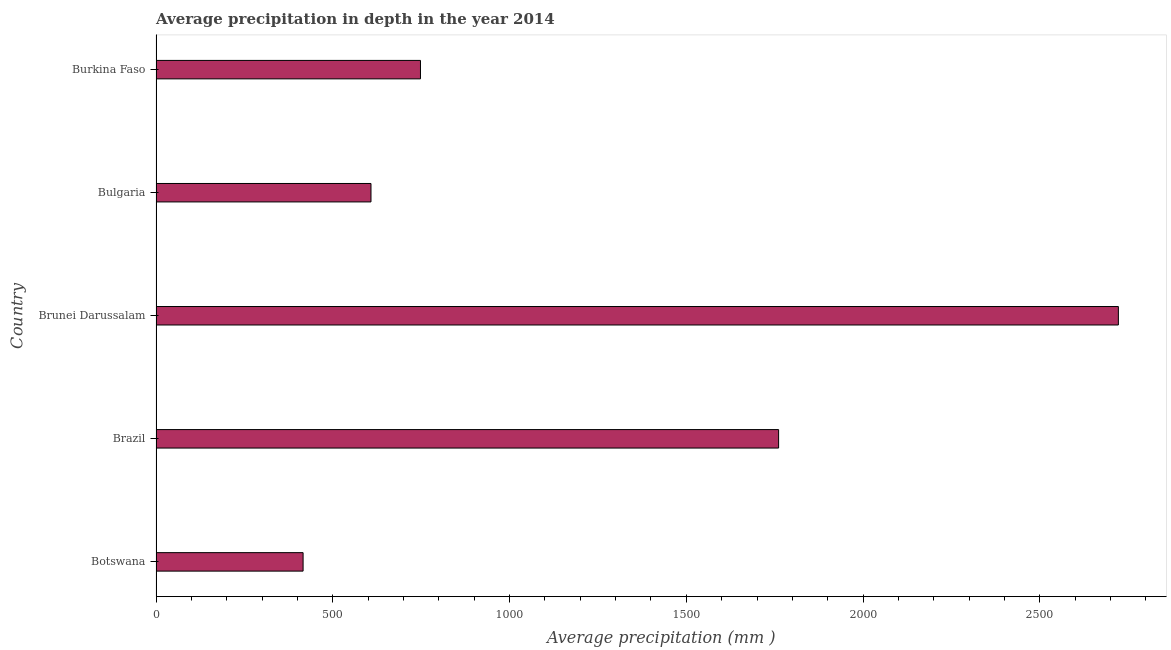Does the graph contain any zero values?
Give a very brief answer. No. What is the title of the graph?
Your answer should be compact. Average precipitation in depth in the year 2014. What is the label or title of the X-axis?
Offer a terse response. Average precipitation (mm ). What is the average precipitation in depth in Botswana?
Give a very brief answer. 416. Across all countries, what is the maximum average precipitation in depth?
Keep it short and to the point. 2722. Across all countries, what is the minimum average precipitation in depth?
Keep it short and to the point. 416. In which country was the average precipitation in depth maximum?
Provide a succinct answer. Brunei Darussalam. In which country was the average precipitation in depth minimum?
Provide a short and direct response. Botswana. What is the sum of the average precipitation in depth?
Your response must be concise. 6255. What is the difference between the average precipitation in depth in Brunei Darussalam and Burkina Faso?
Your response must be concise. 1974. What is the average average precipitation in depth per country?
Your response must be concise. 1251. What is the median average precipitation in depth?
Your answer should be compact. 748. What is the ratio of the average precipitation in depth in Botswana to that in Brazil?
Your answer should be compact. 0.24. Is the difference between the average precipitation in depth in Brunei Darussalam and Burkina Faso greater than the difference between any two countries?
Give a very brief answer. No. What is the difference between the highest and the second highest average precipitation in depth?
Your response must be concise. 961. What is the difference between the highest and the lowest average precipitation in depth?
Make the answer very short. 2306. In how many countries, is the average precipitation in depth greater than the average average precipitation in depth taken over all countries?
Your response must be concise. 2. How many bars are there?
Your answer should be compact. 5. Are all the bars in the graph horizontal?
Give a very brief answer. Yes. How many countries are there in the graph?
Ensure brevity in your answer.  5. What is the Average precipitation (mm ) of Botswana?
Your answer should be compact. 416. What is the Average precipitation (mm ) of Brazil?
Offer a terse response. 1761. What is the Average precipitation (mm ) of Brunei Darussalam?
Your answer should be very brief. 2722. What is the Average precipitation (mm ) of Bulgaria?
Your answer should be compact. 608. What is the Average precipitation (mm ) of Burkina Faso?
Offer a terse response. 748. What is the difference between the Average precipitation (mm ) in Botswana and Brazil?
Provide a short and direct response. -1345. What is the difference between the Average precipitation (mm ) in Botswana and Brunei Darussalam?
Offer a very short reply. -2306. What is the difference between the Average precipitation (mm ) in Botswana and Bulgaria?
Ensure brevity in your answer.  -192. What is the difference between the Average precipitation (mm ) in Botswana and Burkina Faso?
Make the answer very short. -332. What is the difference between the Average precipitation (mm ) in Brazil and Brunei Darussalam?
Keep it short and to the point. -961. What is the difference between the Average precipitation (mm ) in Brazil and Bulgaria?
Your answer should be very brief. 1153. What is the difference between the Average precipitation (mm ) in Brazil and Burkina Faso?
Provide a short and direct response. 1013. What is the difference between the Average precipitation (mm ) in Brunei Darussalam and Bulgaria?
Offer a very short reply. 2114. What is the difference between the Average precipitation (mm ) in Brunei Darussalam and Burkina Faso?
Offer a terse response. 1974. What is the difference between the Average precipitation (mm ) in Bulgaria and Burkina Faso?
Your answer should be very brief. -140. What is the ratio of the Average precipitation (mm ) in Botswana to that in Brazil?
Make the answer very short. 0.24. What is the ratio of the Average precipitation (mm ) in Botswana to that in Brunei Darussalam?
Give a very brief answer. 0.15. What is the ratio of the Average precipitation (mm ) in Botswana to that in Bulgaria?
Provide a short and direct response. 0.68. What is the ratio of the Average precipitation (mm ) in Botswana to that in Burkina Faso?
Offer a very short reply. 0.56. What is the ratio of the Average precipitation (mm ) in Brazil to that in Brunei Darussalam?
Make the answer very short. 0.65. What is the ratio of the Average precipitation (mm ) in Brazil to that in Bulgaria?
Provide a short and direct response. 2.9. What is the ratio of the Average precipitation (mm ) in Brazil to that in Burkina Faso?
Ensure brevity in your answer.  2.35. What is the ratio of the Average precipitation (mm ) in Brunei Darussalam to that in Bulgaria?
Your answer should be compact. 4.48. What is the ratio of the Average precipitation (mm ) in Brunei Darussalam to that in Burkina Faso?
Your answer should be compact. 3.64. What is the ratio of the Average precipitation (mm ) in Bulgaria to that in Burkina Faso?
Your answer should be compact. 0.81. 